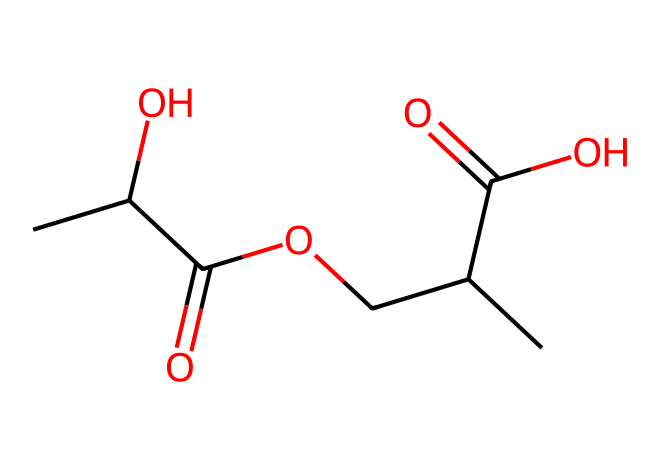What is the total number of carbon atoms in the structure? By examining the SMILES representation, we count the 'C' symbols indicating carbon atoms. There are a total of 7 carbon atoms present in the chemical structure.
Answer: 7 How many ester functional groups are present in this chemical? The presence of ester groups can be identified by looking for the 'C(=O)O' notation in the SMILES. In this structure, there are two distinct ester groups.
Answer: 2 What type of polymerization process is involved in PLA synthesis? Polylactic acid (PLA) is synthesized through a process called ring-opening polymerization, which is typically employed for lactide derived from lactic acid.
Answer: ring-opening polymerization What is the degree of saturation of this chemical? To determine the degree of saturation, we look for double bonds present in the structure. There are two carbonyl (C=O) groups indicating two saturations. Therefore, the degree of saturation corresponds to the presence of those double bonds.
Answer: 2 Is this polymer biodegradable? Polylactic acid (PLA) is known for being biodegradable, as it is derived from renewable resources like corn starch or sugarcane and can decompose under certain conditions.
Answer: biodegradable What functional groups are present in this chemical? By analyzing the SMILES structure, we identify the functional groups as carboxylic acids (-COOH) and esters (-COO-). Both of these groups are evident in the given chemical structure.
Answer: carboxylic acids and esters What is the stereochemistry of the lactide used in PLA? The lactide used in PLA can be either L-lactide or D-lactide, which are stereoisomers. This indicates that PLA can exhibit stereochemistry based on the source of lactic acid.
Answer: L-lactide or D-lactide 